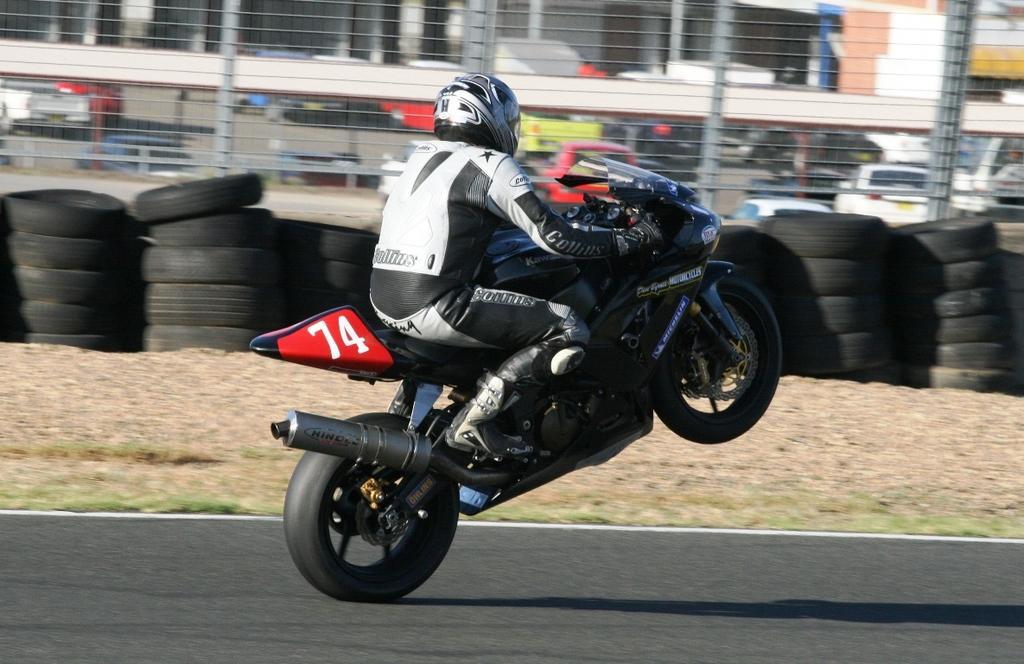In one or two sentences, can you explain what this image depicts? In this image we can see a person wearing jacket and helmet is riding motorcycles on the road. In the background, we can see a group of tyres, fence, buildings and cars parked on the ground. 